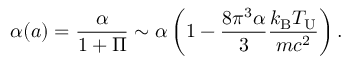Convert formula to latex. <formula><loc_0><loc_0><loc_500><loc_500>\alpha ( a ) = \frac { \alpha } { 1 + \Pi } \sim \alpha \left ( 1 - \frac { 8 \pi ^ { 3 } \alpha } { 3 } \frac { k _ { B } T _ { U } } { m c ^ { 2 } } \right ) .</formula> 